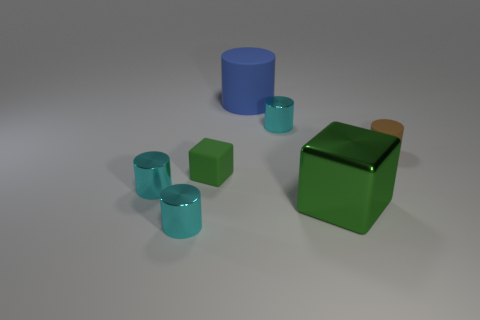Subtract all purple blocks. How many cyan cylinders are left? 3 Subtract all blue cylinders. How many cylinders are left? 4 Subtract all small rubber cylinders. How many cylinders are left? 4 Subtract 2 cylinders. How many cylinders are left? 3 Subtract all yellow cylinders. Subtract all purple spheres. How many cylinders are left? 5 Add 1 big purple shiny balls. How many objects exist? 8 Subtract all cylinders. How many objects are left? 2 Subtract all matte blocks. Subtract all brown objects. How many objects are left? 5 Add 1 small cyan metal cylinders. How many small cyan metal cylinders are left? 4 Add 5 small green spheres. How many small green spheres exist? 5 